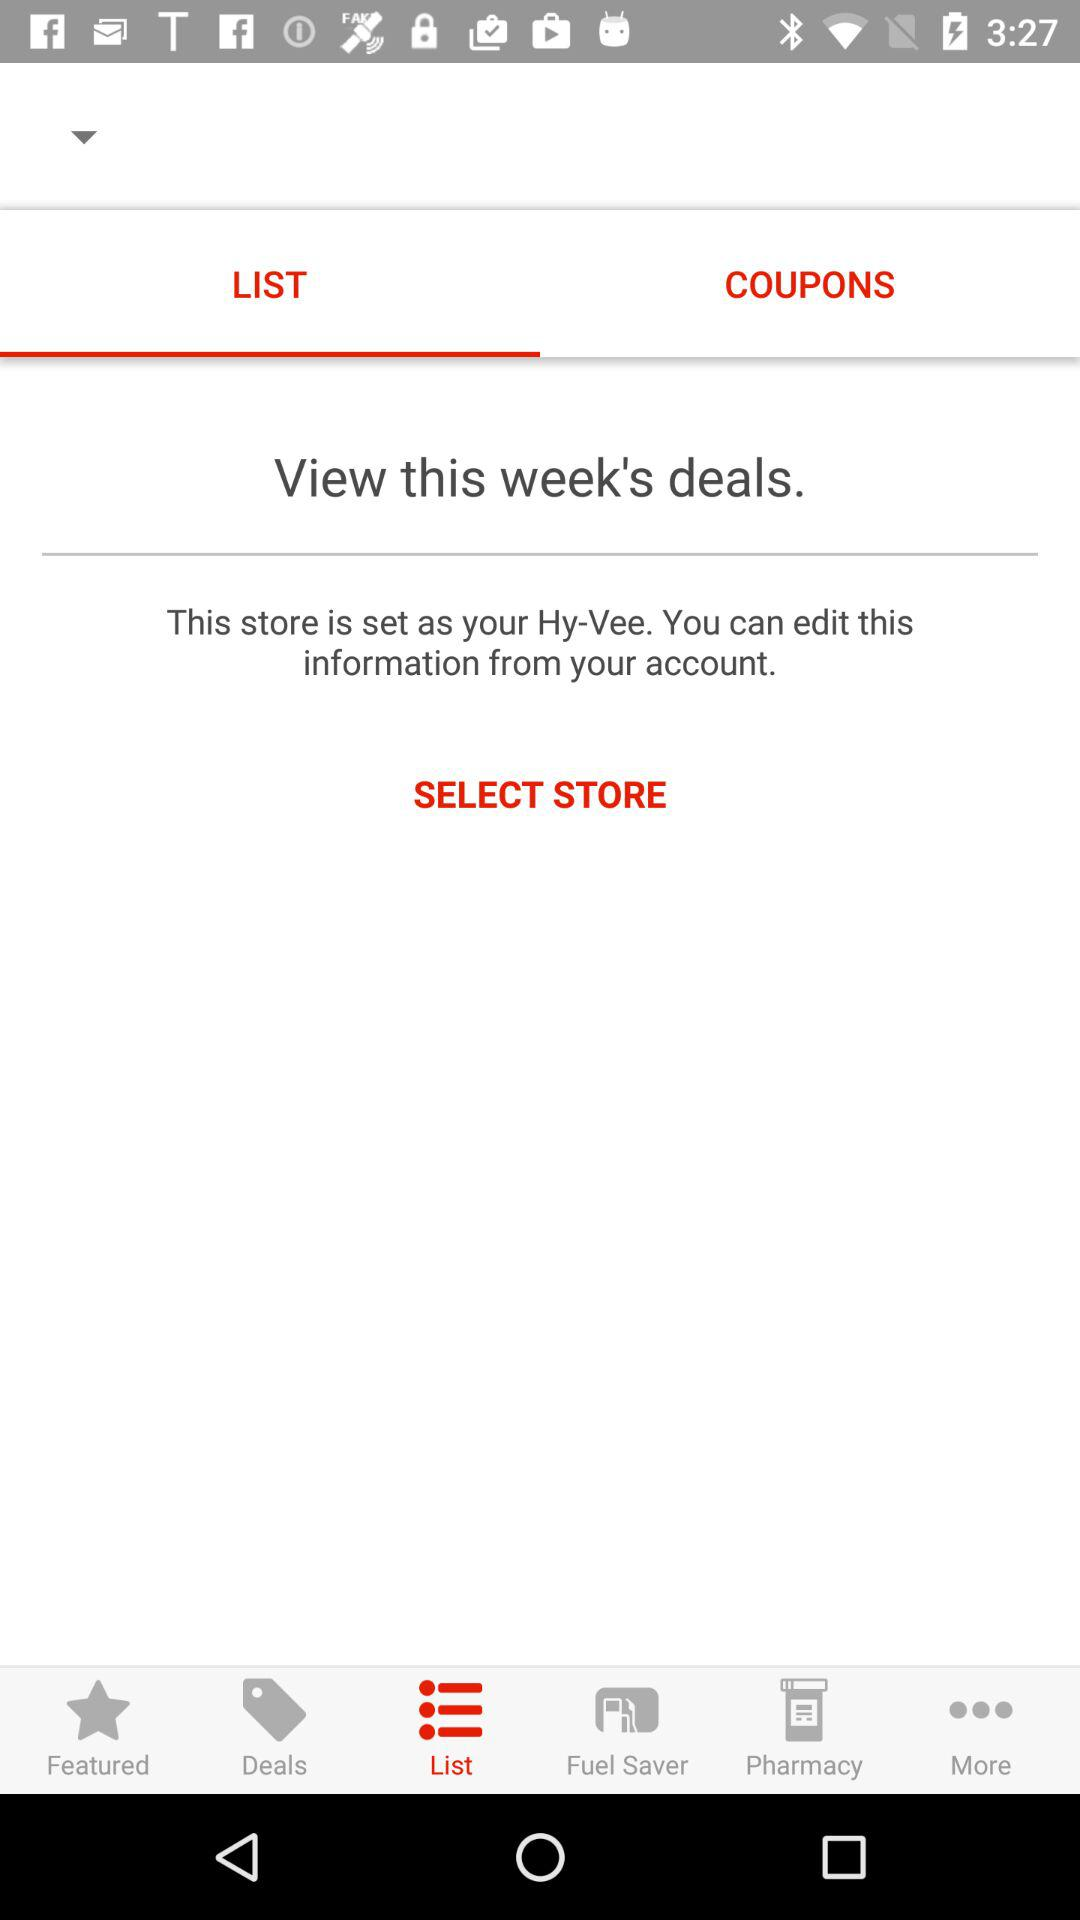From where can a user edit the information? The user can edit the information from the user's account. 